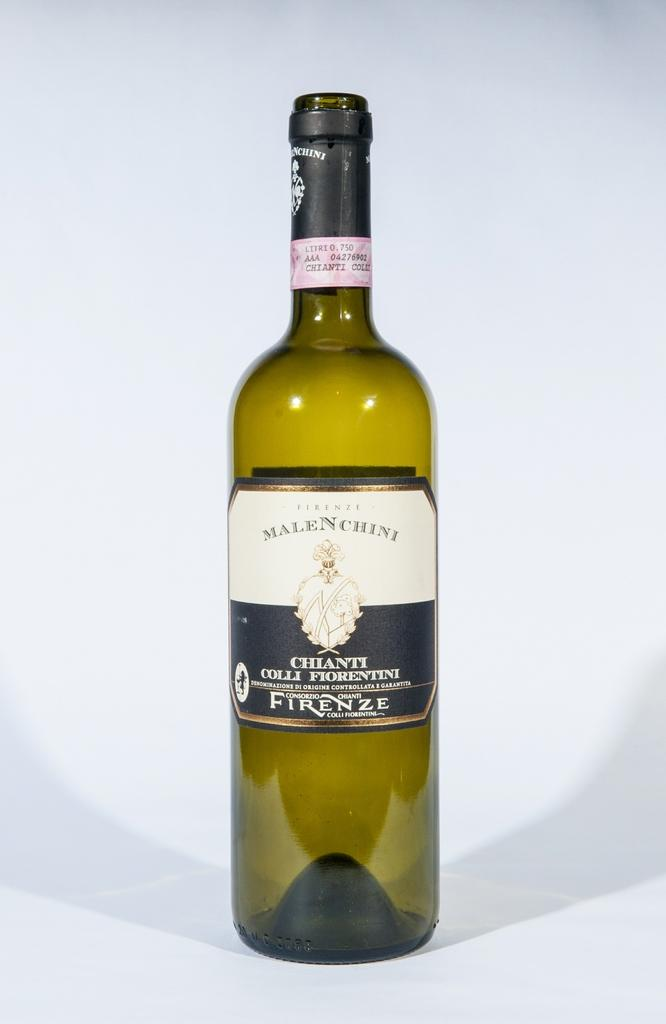What object can be seen in the image? There is a bottle in the image. What type of sweater is being worn by the bottle in the image? There is no sweater present in the image, as the main subject is a bottle. 